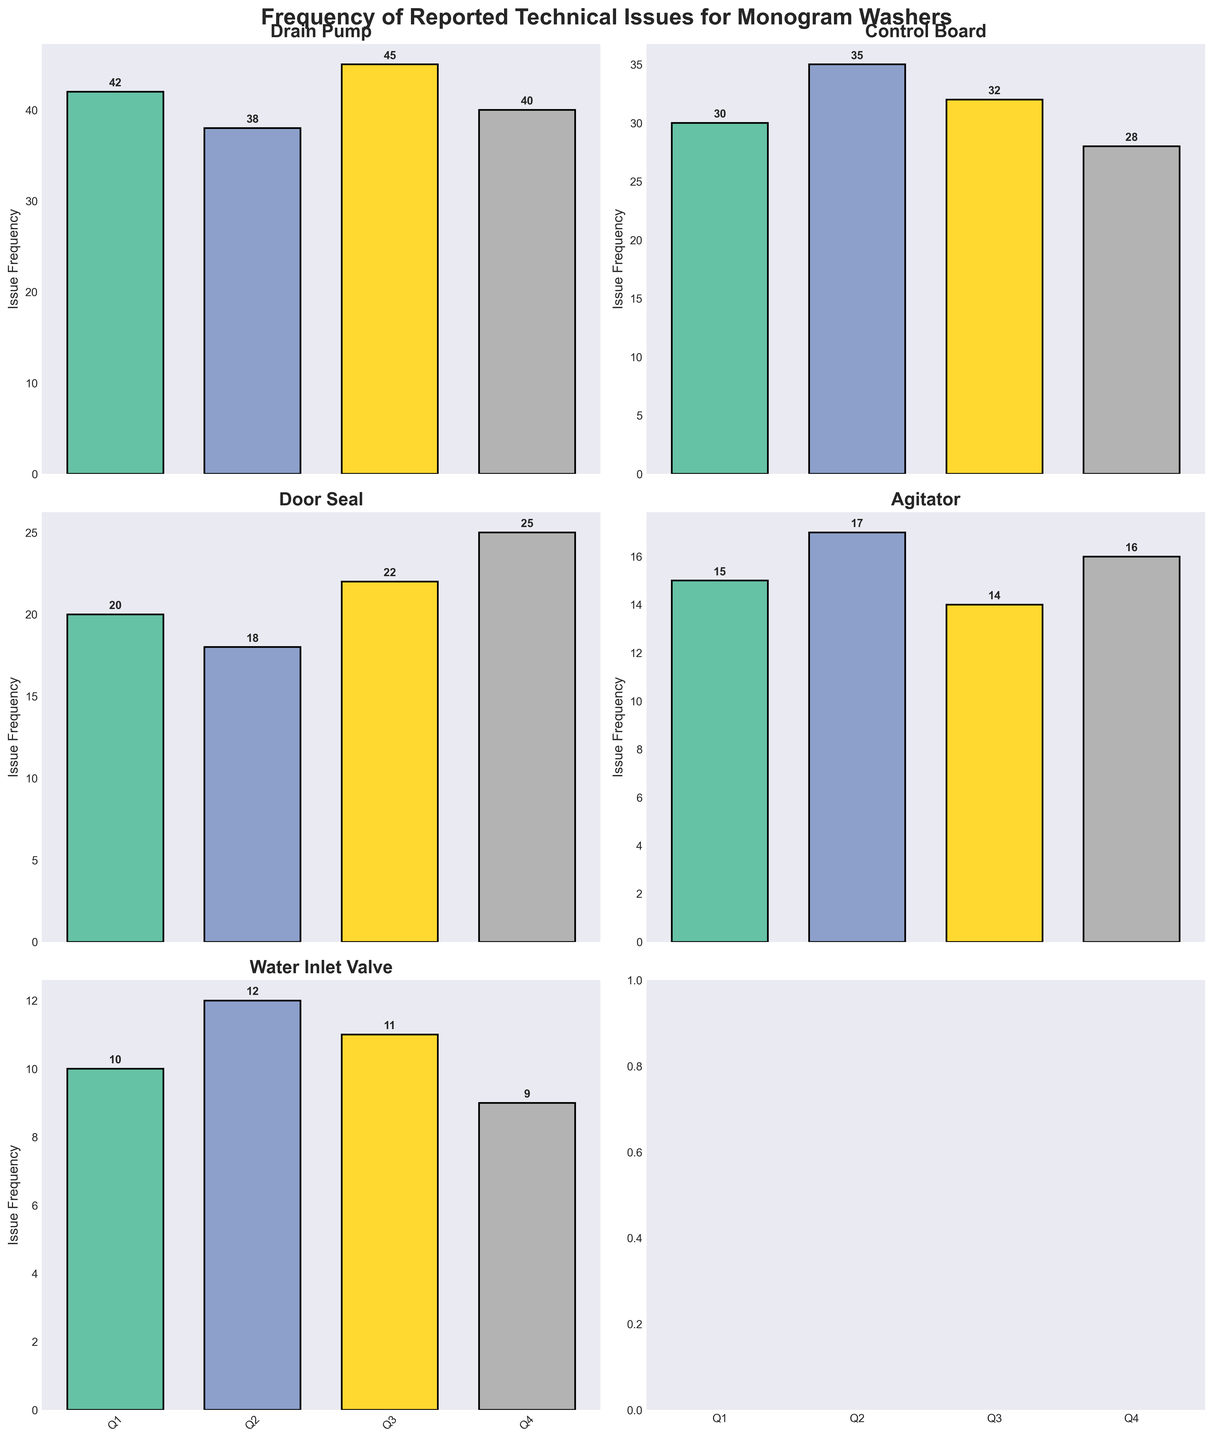Which component had the highest issue frequency in Q3? The heights of the bars in the Q3 column in each subplot represent issue frequencies. The Drain Pump has the highest bar in Q3.
Answer: Drain Pump How many components have a decrease in issue frequency from Q2 to Q3? Compare the height of the bars for Q2 and Q3 for each component. The Drain Pump, Control Board, and Agitator show a decrease in issue frequency from Q2 to Q3.
Answer: 3 What is the total issue frequency for the Door Seal across all quarters? Sum the heights of the bars in the Door Seal subplot for all quarters: 20 (Q1) + 18 (Q2) + 22 (Q3) + 25 (Q4).
Answer: 85 Which quarter had the highest total issue frequency across all components? Sum the heights of the bars for each quarter across all subplots and compare. Q1: 42 + 30 + 20 + 15 + 10 = 117, Q2: 38 + 35 + 18 + 17 + 12 = 120, Q3: 45 + 32 + 22 + 14 + 11 = 124, Q4: 40 + 28 + 25 + 16 + 9 = 118. Q3 is the highest.
Answer: Q3 Does the Agitator ever have an issue frequency higher than the Control Board? Visually compare the heights of the bars in the Agitator and Control Board subplots for all quarters. The Control Board has a higher issue frequency in all quarters.
Answer: No What is the trend of the issue frequency for the Control Board across the quarters? Observe the height of the bars for the Control Board subplot from Q1 to Q4. The frequencies are: 30 (Q1), 35 (Q2), 32 (Q3), and 28 (Q4). The trend is first increasing in Q2, then decreasing in Q3 and Q4.
Answer: Increasing then decreasing Which component has the most consistent issue frequency across all quarters? Compare the variability of the bar heights in each subplot. The Agitator's bars have smaller fluctuations: 15 (Q1), 17 (Q2), 14 (Q3), 16 (Q4).
Answer: Agitator Is there any component with an increasing trend in issue frequency from Q1 to Q4? Check the height of the bars for each component from Q1 to Q4. The Door Seal shows an increase: 20 (Q1), 18 (Q2), 22 (Q3), 25 (Q4).
Answer: Door Seal What is the average issue frequency for the Water Inlet Valve over the four quarters? Sum the issue frequencies for the Water Inlet Valve and divide by the number of quarters: (10 + 12 + 11 + 9) / 4.
Answer: 10.5 